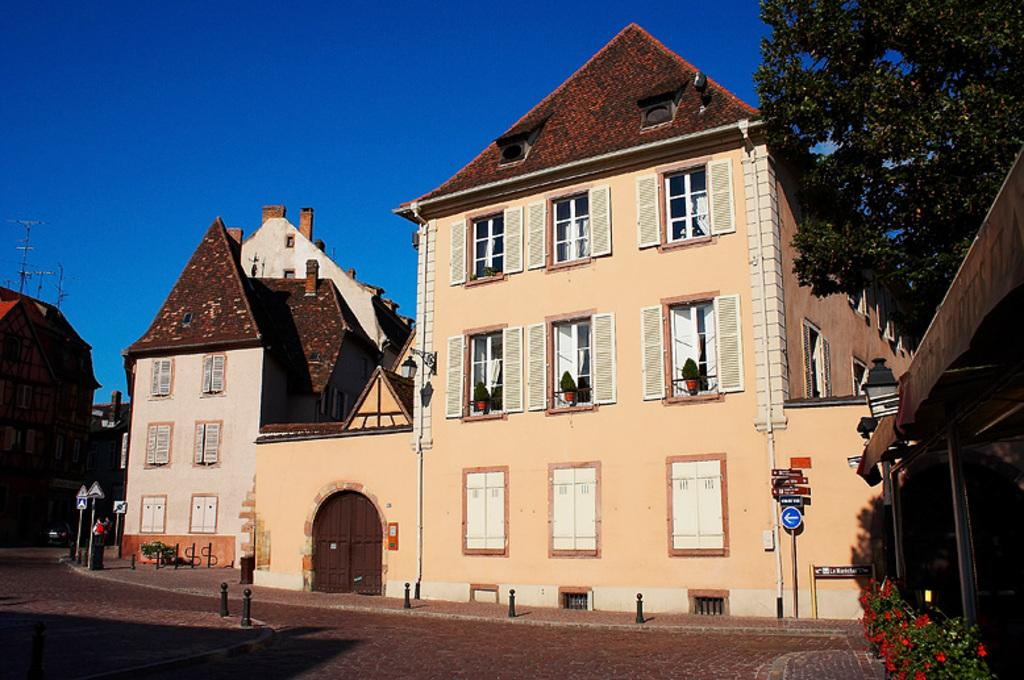What type of structures can be seen in the image? There are buildings in the image. What type of vegetation is present in the image? There are trees and plants in the image. What architectural features can be seen in the image? There are windows, flower pots, boards, and poles in the image. What is the ground surface like in the image? There is a road at the bottom of the image. What part of the natural environment is visible in the image? The sky is visible at the top of the image. Can you tell me how many fictional characters are depicted in the image? There are no fictional characters present in the image; it features real-world objects and structures. What type of mind can be seen in the image? There is no mind present in the image; it is a visual representation of physical objects and structures. 